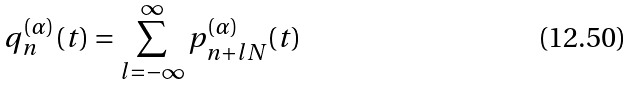Convert formula to latex. <formula><loc_0><loc_0><loc_500><loc_500>q _ { n } ^ { ( \alpha ) } ( t ) = \sum _ { l = - \infty } ^ { \infty } p _ { n + l N } ^ { ( \alpha ) } ( t )</formula> 